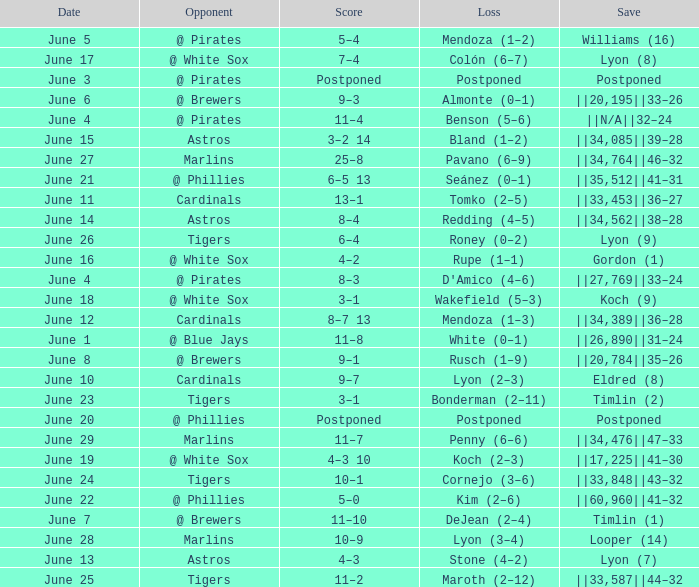Who is the opponent with a save of ||33,453||36–27? Cardinals. 